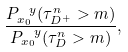Convert formula to latex. <formula><loc_0><loc_0><loc_500><loc_500>\frac { P ^ { \ y } _ { x _ { 0 } } ( \tau _ { D ^ { + } } ^ { n } > m ) } { P ^ { \ y } _ { x _ { 0 } } ( \tau _ { D } ^ { n } > m ) } ,</formula> 